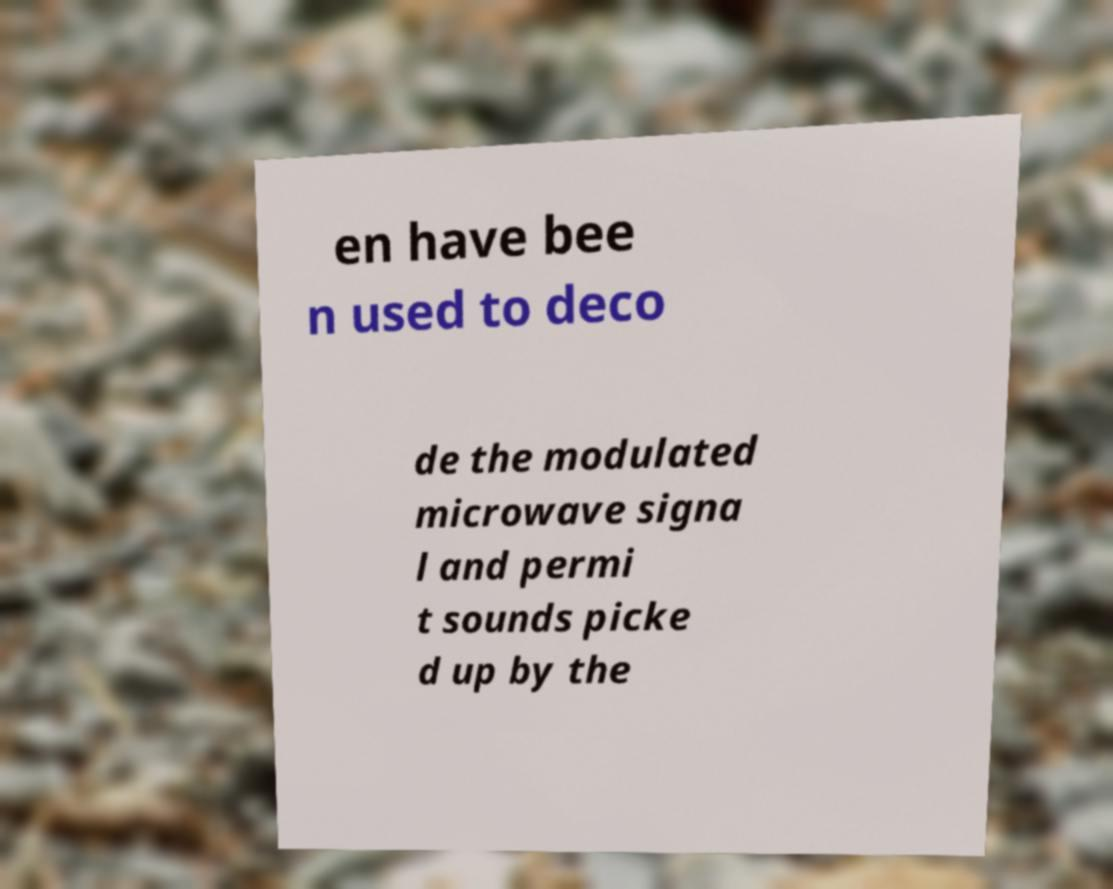For documentation purposes, I need the text within this image transcribed. Could you provide that? en have bee n used to deco de the modulated microwave signa l and permi t sounds picke d up by the 